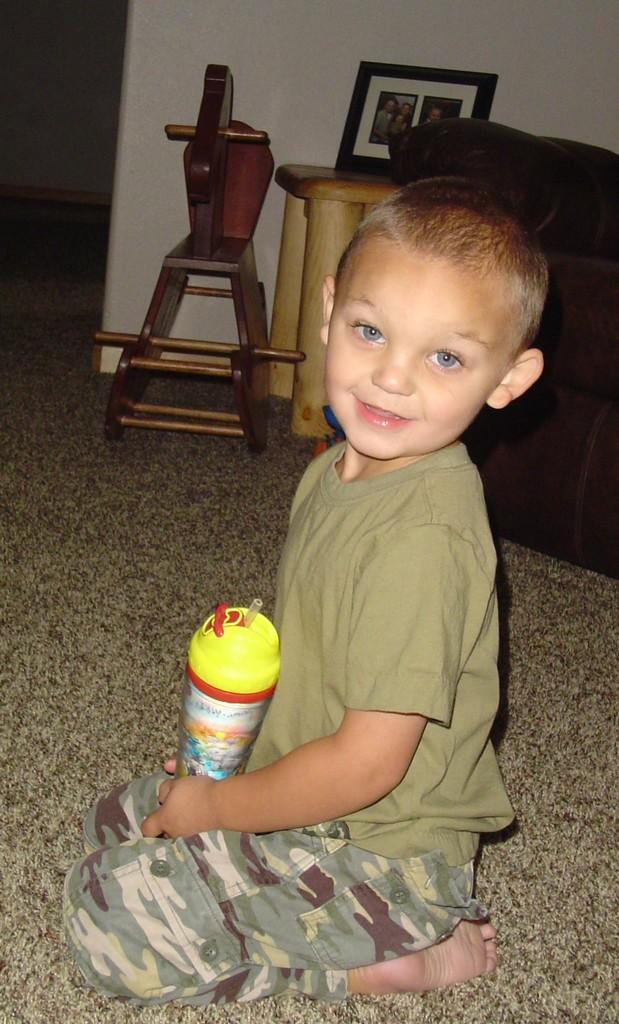What is the main subject of the image? There is a child in the image. What is the child doing in the image? The child is sitting on the floor. What can be seen in the background of the image? There is a stool in the background of the image. What is on the stool in the background of the image? There is a photo frame on the stool in the background of the image. How does the child rub their hands together in the image? There is no indication in the image that the child is rubbing their hands together. 